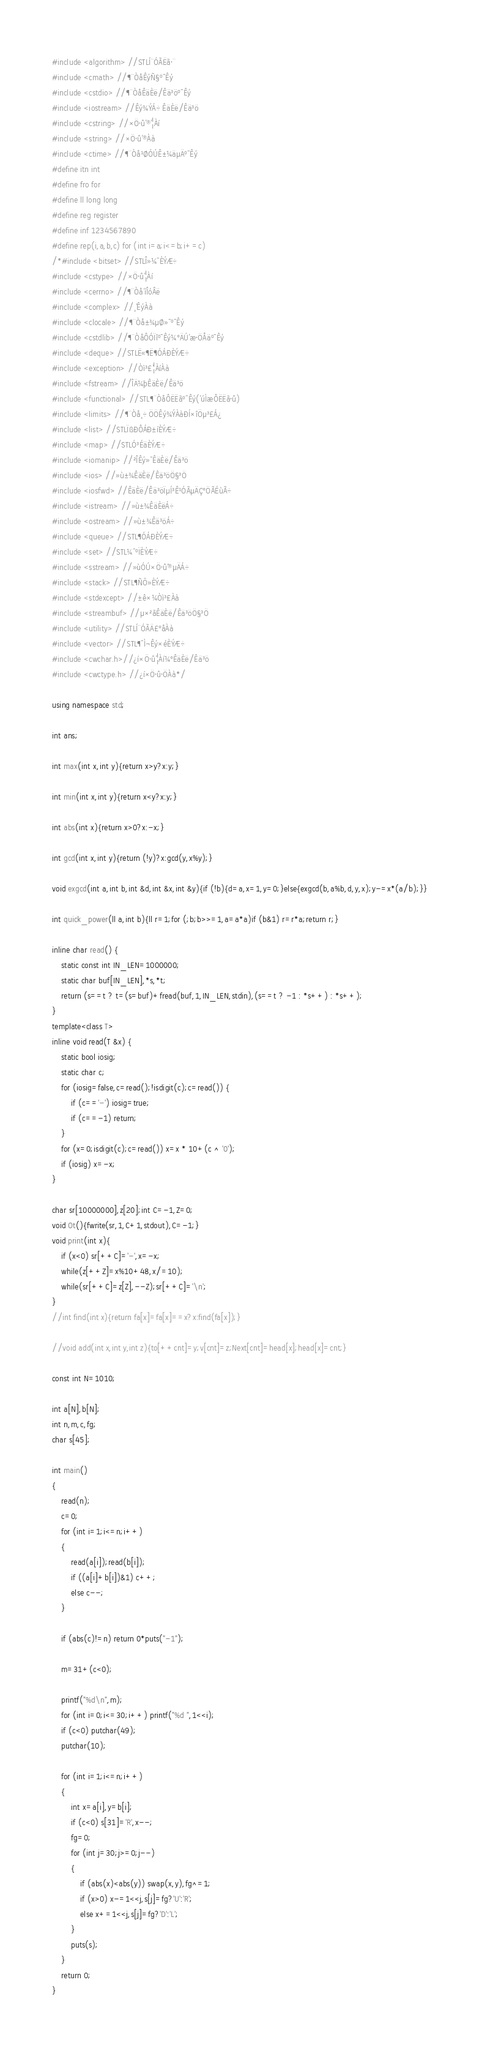<code> <loc_0><loc_0><loc_500><loc_500><_C++_>#include <algorithm> //STLÍ¨ÓÃËã·¨
#include <cmath> //¶¨ÒåÊýÑ§º¯Êý
#include <cstdio> //¶¨ÒåÊäÈë/Êä³öº¯Êý
#include <iostream> //Êý¾ÝÁ÷ÊäÈë/Êä³ö
#include <cstring> //×Ö·û´®´¦Àí
#include <string> //×Ö·û´®Àà
#include <ctime> //¶¨Òå¹ØÓÚÊ±¼äµÄº¯Êý
#define itn int
#define fro for
#define ll long long
#define reg register
#define inf 1234567890
#define rep(i,a,b,c) for (int i=a;i<=b;i+=c)
/*#include <bitset> //STLÎ»¼¯ÈÝÆ÷
#include <cstype> //×Ö·û´¦Àí
#include <cerrno> //¶¨Òå´íÎóÂë
#include <complex> //¸´ÊýÀà
#include <clocale> //¶¨Òå±¾µØ»¯º¯Êý
#include <cstdlib> //¶¨ÒåÔÓÏîº¯Êý¼°ÄÚ´æ·ÖÅäº¯Êý
#include <deque> //STLË«¶Ë¶ÓÁÐÈÝÆ÷
#include <exception> //Òì³£´¦ÀíÀà
#include <fstream> //ÎÄ¼þÊäÈë/Êä³ö
#include <functional> //STL¶¨ÒåÔËËãº¯Êý(´úÌæÔËËã·û)
#include <limits> //¶¨Òå¸÷ÖÖÊý¾ÝÀàÐÍ×îÖµ³£Á¿
#include <list> //STLÏßÐÔÁÐ±íÈÝÆ÷
#include <map> //STLÓ³ÉäÈÝÆ÷
#include <iomanip> //²ÎÊý»¯ÊäÈë/Êä³ö
#include <ios> //»ù±¾ÊäÈë/Êä³öÖ§³Ö
#include <iosfwd> //ÊäÈë/Êä³öÏµÍ³Ê¹ÓÃµÄÇ°ÖÃÉùÃ÷
#include <istream> //»ù±¾ÊäÈëÁ÷
#include <ostream> //»ù±¾Êä³öÁ÷
#include <queue> //STL¶ÓÁÐÈÝÆ÷
#include <set> //STL¼¯ºÏÈÝÆ÷
#include <sstream> //»ùÓÚ×Ö·û´®µÄÁ÷
#include <stack> //STL¶ÑÕ»ÈÝÆ÷
#include <stdexcept> //±ê×¼Òì³£Àà
#include <streambuf> //µ×²ãÊäÈë/Êä³öÖ§³Ö
#include <utility> //STLÍ¨ÓÃÄ£°åÀà
#include <vector> //STL¶¯Ì¬Êý×éÈÝÆ÷
#include <cwchar.h>//¿í×Ö·û´¦Àí¼°ÊäÈë/Êä³ö
#include <cwctype.h> //¿í×Ö·û·ÖÀà*/

using namespace std;

int ans;

int max(int x,int y){return x>y?x:y;}

int min(int x,int y){return x<y?x:y;}

int abs(int x){return x>0?x:-x;}

int gcd(int x,int y){return (!y)?x:gcd(y,x%y);}

void exgcd(int a,int b,int &d,int &x,int &y){if (!b){d=a,x=1,y=0;}else{exgcd(b,a%b,d,y,x);y-=x*(a/b);}}

int quick_power(ll a,int b){ll r=1;for (;b;b>>=1,a=a*a)if (b&1) r=r*a;return r;}

inline char read() {
	static const int IN_LEN=1000000;
	static char buf[IN_LEN],*s,*t;
	return (s==t ? t=(s=buf)+fread(buf,1,IN_LEN,stdin),(s==t ? -1 : *s++) : *s++);
}
template<class T>
inline void read(T &x) {
	static bool iosig;
	static char c;
	for (iosig=false,c=read();!isdigit(c);c=read()) {
		if (c=='-') iosig=true;
		if (c==-1) return;
	}
	for (x=0;isdigit(c);c=read()) x=x * 10+(c ^ '0');
	if (iosig) x=-x;
}

char sr[10000000],z[20];int C=-1,Z=0;
void Ot(){fwrite(sr,1,C+1,stdout),C=-1;}
void print(int x){
	if (x<0) sr[++C]='-',x=-x;
	while(z[++Z]=x%10+48,x/=10);
	while(sr[++C]=z[Z],--Z);sr[++C]='\n';
}
//int find(int x){return fa[x]=fa[x]==x?x:find(fa[x]);}

//void add(int x,int y,int z){to[++cnt]=y;v[cnt]=z;Next[cnt]=head[x];head[x]=cnt;}

const int N=1010;

int a[N],b[N];
int n,m,c,fg;
char s[45];

int main()
{
	read(n);
	c=0;
	for (int i=1;i<=n;i++)
	{
		read(a[i]);read(b[i]);
		if ((a[i]+b[i])&1) c++;
		else c--;
	}

	if (abs(c)!=n) return 0*puts("-1");

	m=31+(c<0);

	printf("%d\n",m);
	for (int i=0;i<=30;i++) printf("%d ",1<<i);
	if (c<0) putchar(49);
	putchar(10);

	for (int i=1;i<=n;i++)
	{
		int x=a[i],y=b[i];
		if (c<0) s[31]='R',x--;
		fg=0;
		for (int j=30;j>=0;j--)
		{
			if (abs(x)<abs(y)) swap(x,y),fg^=1;
			if (x>0) x-=1<<j,s[j]=fg?'U':'R';
			else x+=1<<j,s[j]=fg?'D':'L';
		}
		puts(s);
	}
	return 0;
}






</code> 